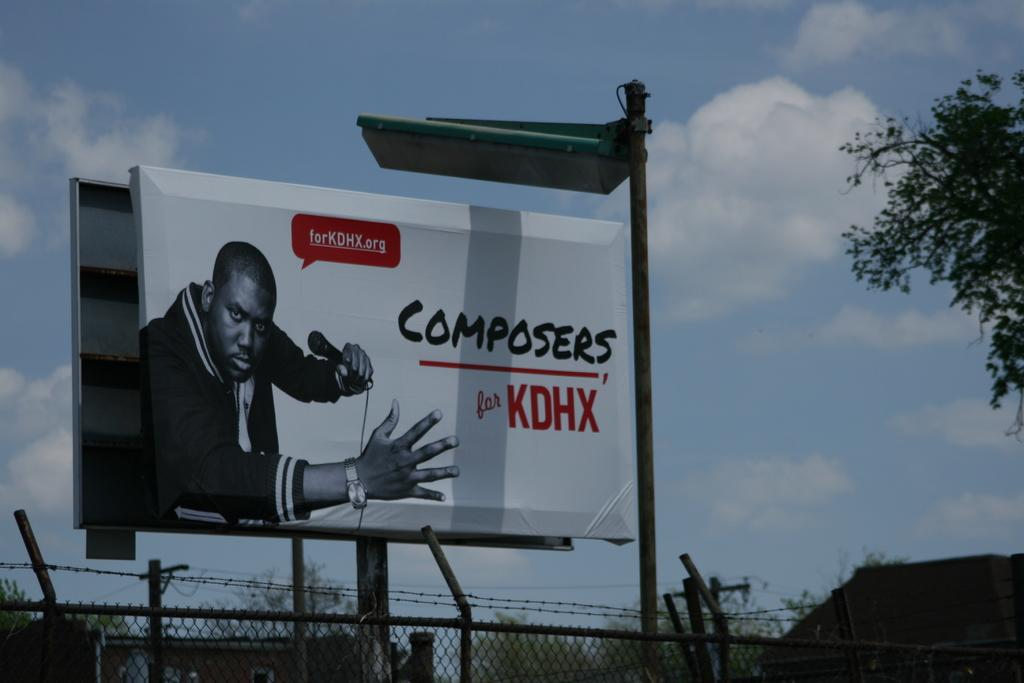<image>
Provide a brief description of the given image. A billboard advertising Composers for KDHX on the side of a street. 